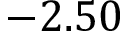Convert formula to latex. <formula><loc_0><loc_0><loc_500><loc_500>- 2 . 5 0</formula> 